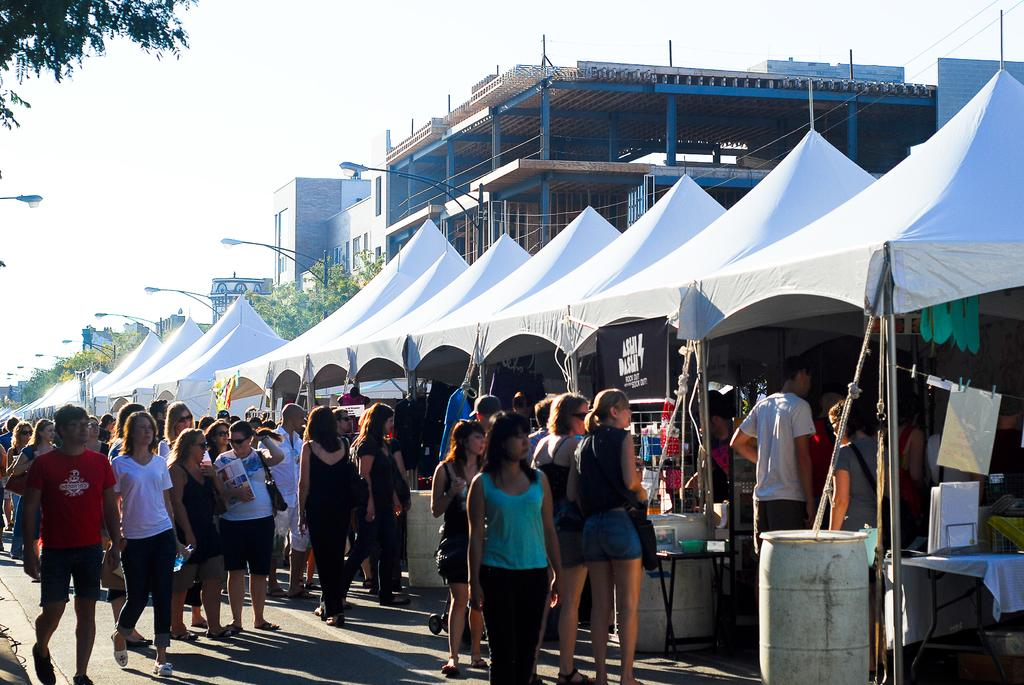What type of structures can be seen in the image? There are buildings in the image. What other objects are present in the image? There are light poles, trees, tents, a crowd, drums, and a banner in the image. Can you describe the environment in the image? The image shows a combination of urban and natural elements, with buildings, light poles, and trees, as well as tents and a crowd. What might be happening in the image? The presence of drums and a crowd suggests that there may be an event or gathering taking place. What is the purpose of the banner in the image? The banner may be used for advertising, providing information, or promoting a cause or event. What type of liquid is being poured from the rail in the image? There is no rail or liquid present in the image. What type of prison can be seen in the image? There is no prison present in the image. 